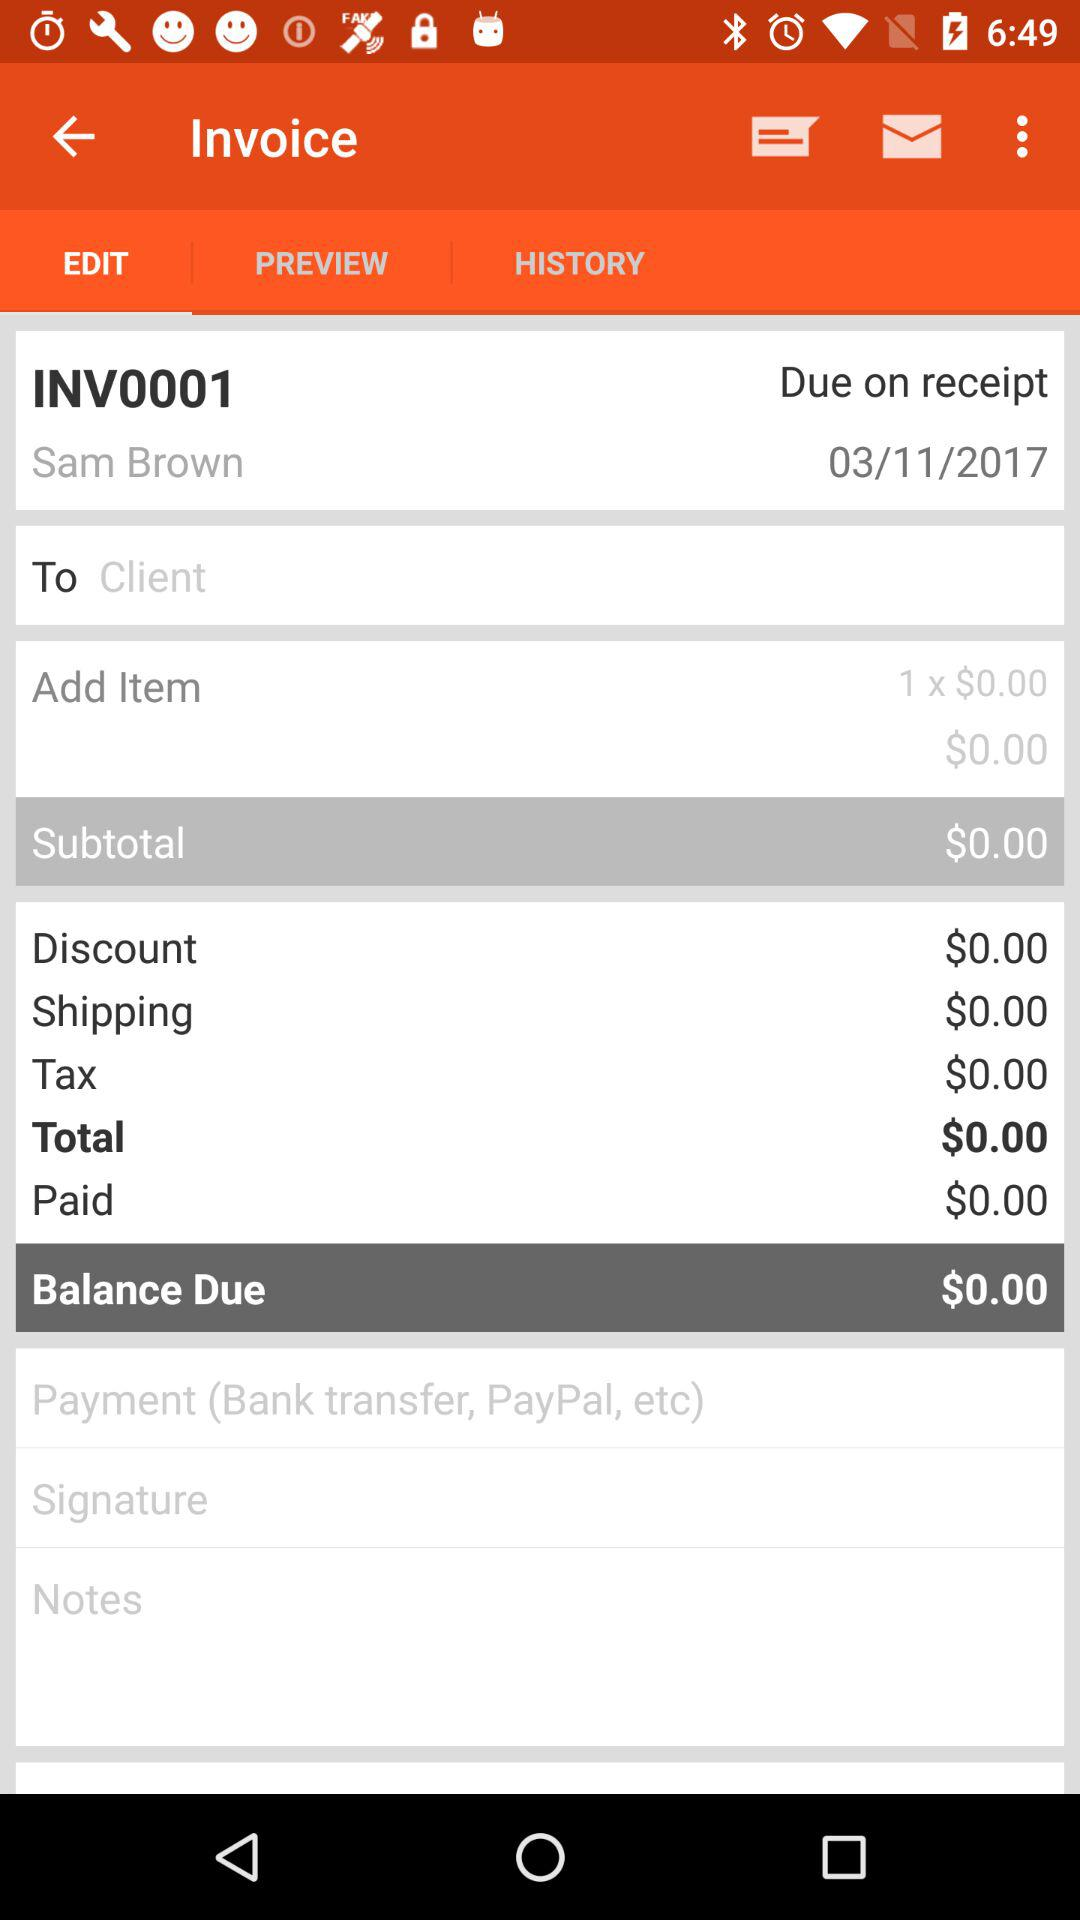What is the total amount of the invoice?
Answer the question using a single word or phrase. $0.00 